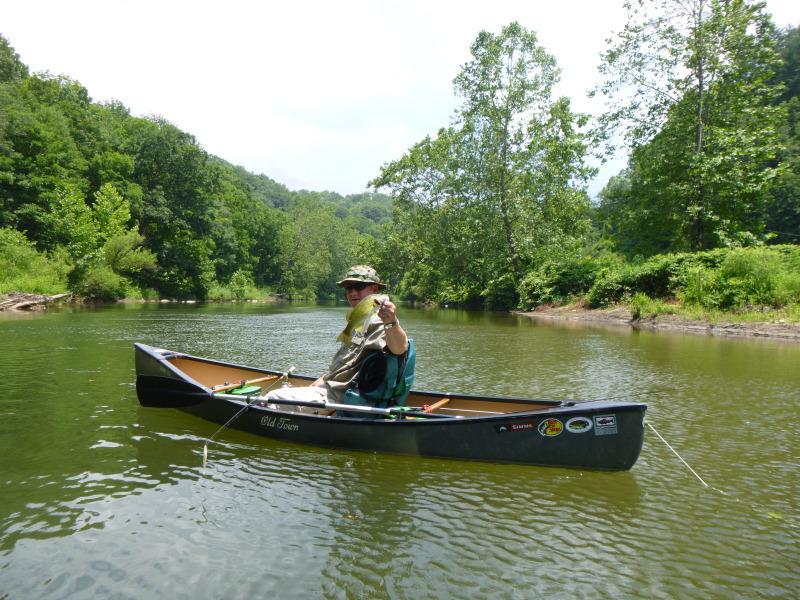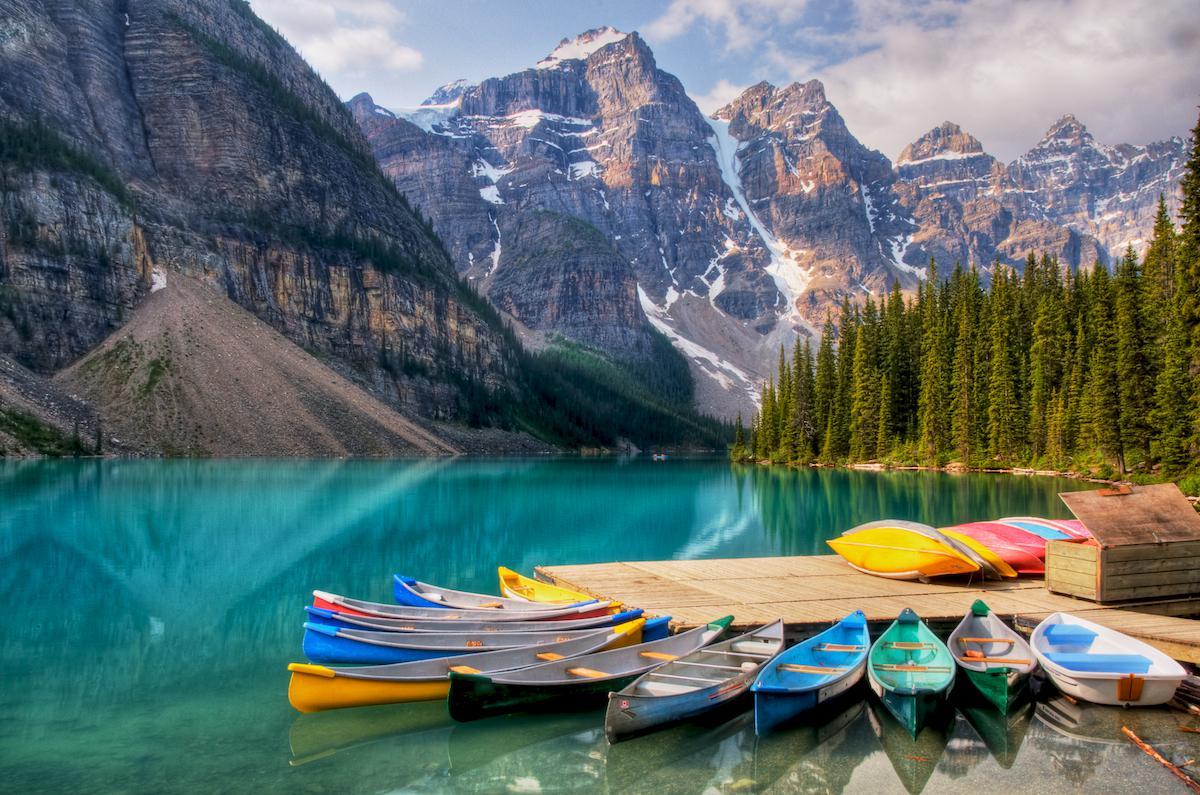The first image is the image on the left, the second image is the image on the right. Considering the images on both sides, is "One image contains only canoes that are red." valid? Answer yes or no. No. 